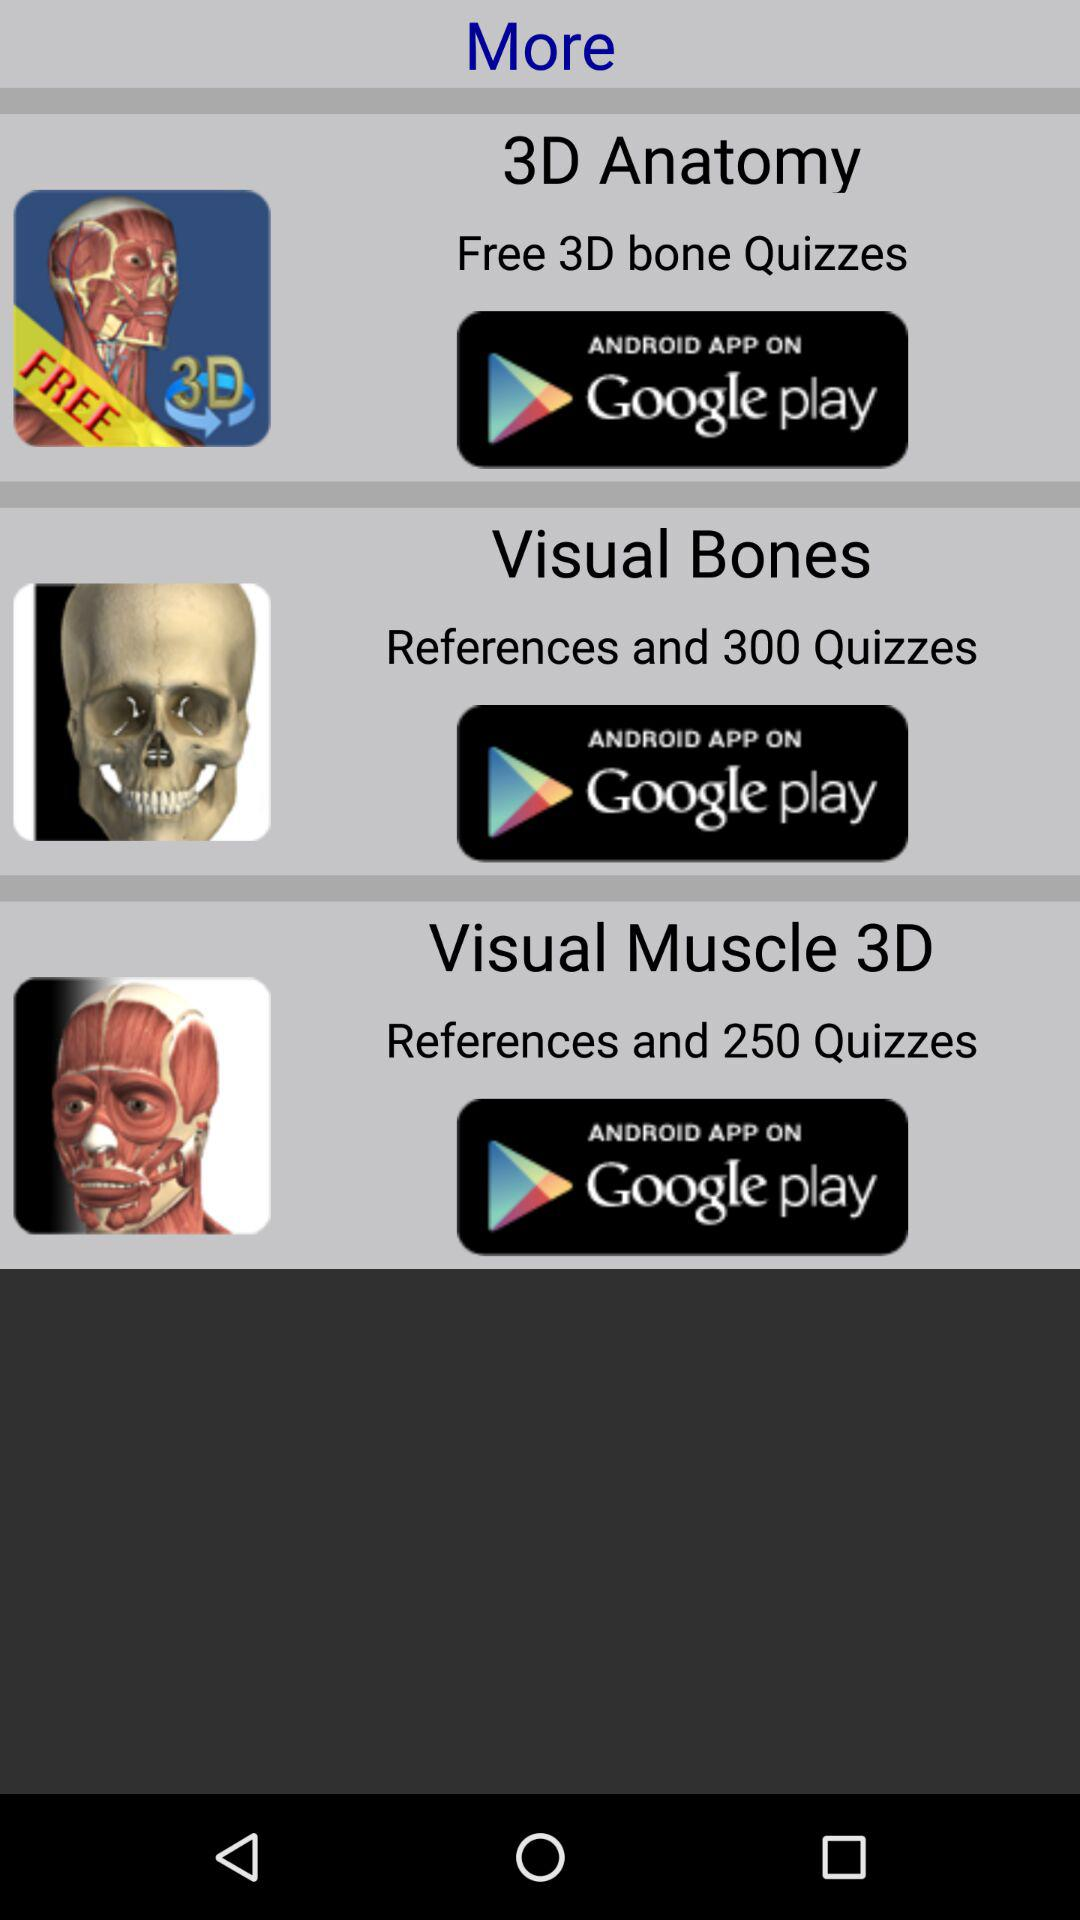What is the number of quizzes in "Visual Bones"? The number of quizzes in "Visual Bones" is 300. 